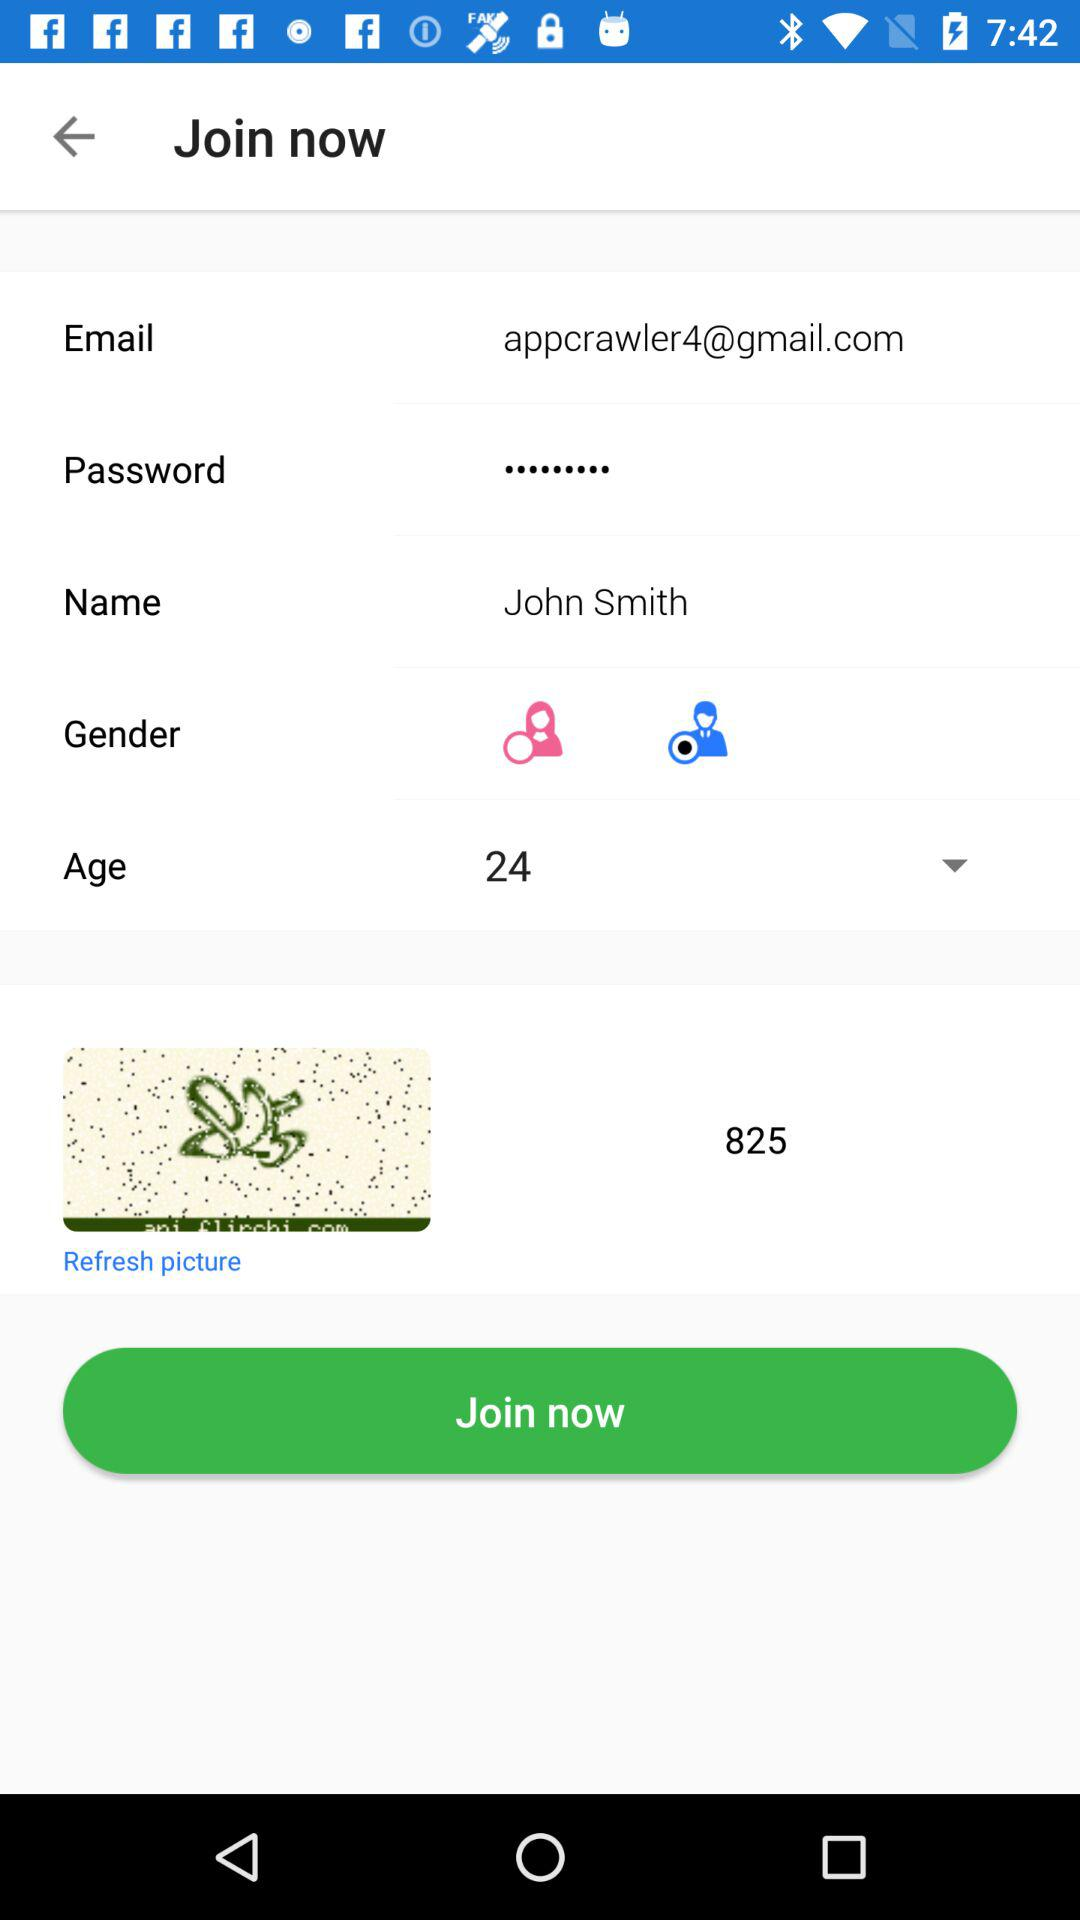How tall is John Smith?
When the provided information is insufficient, respond with <no answer>. <no answer> 